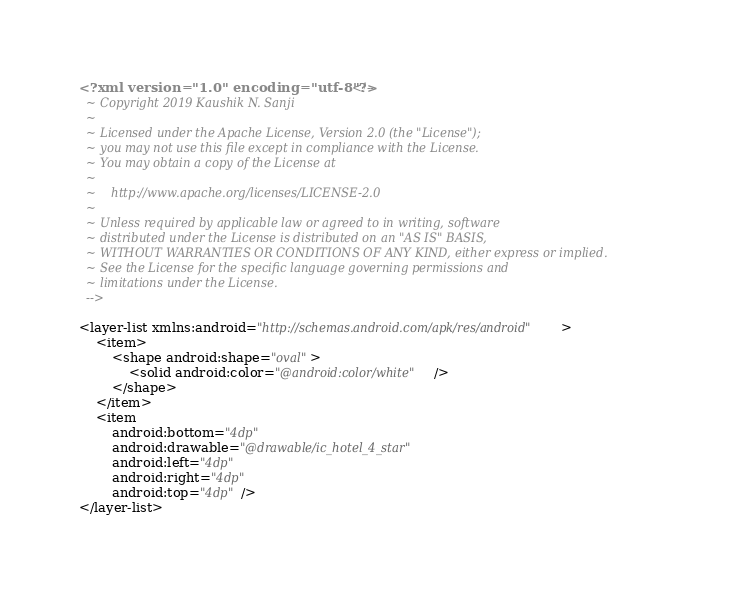Convert code to text. <code><loc_0><loc_0><loc_500><loc_500><_XML_><?xml version="1.0" encoding="utf-8"?><!--
  ~ Copyright 2019 Kaushik N. Sanji
  ~
  ~ Licensed under the Apache License, Version 2.0 (the "License");
  ~ you may not use this file except in compliance with the License.
  ~ You may obtain a copy of the License at
  ~
  ~    http://www.apache.org/licenses/LICENSE-2.0
  ~
  ~ Unless required by applicable law or agreed to in writing, software
  ~ distributed under the License is distributed on an "AS IS" BASIS,
  ~ WITHOUT WARRANTIES OR CONDITIONS OF ANY KIND, either express or implied.
  ~ See the License for the specific language governing permissions and
  ~ limitations under the License.
  -->

<layer-list xmlns:android="http://schemas.android.com/apk/res/android">
    <item>
        <shape android:shape="oval">
            <solid android:color="@android:color/white" />
        </shape>
    </item>
    <item
        android:bottom="4dp"
        android:drawable="@drawable/ic_hotel_4_star"
        android:left="4dp"
        android:right="4dp"
        android:top="4dp" />
</layer-list></code> 